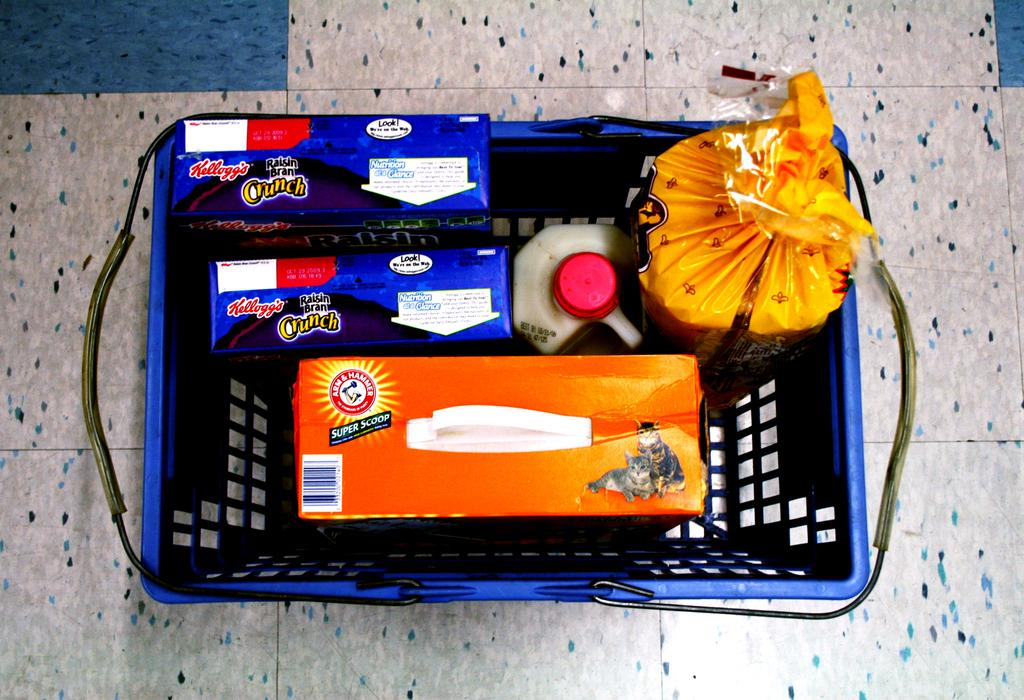What object in the image is used for holding or carrying items? There is a basket in the image, which is used for holding or carrying items. What is inside the basket in the image? The basket contains boxes. What type of container with a lid can be seen in the image? There is a container with a lid in the image. What other item is present in the image? There is a packet in the image. What type of skin can be seen on the boxes in the image? There is no skin visible in the image; the boxes are inanimate objects. 